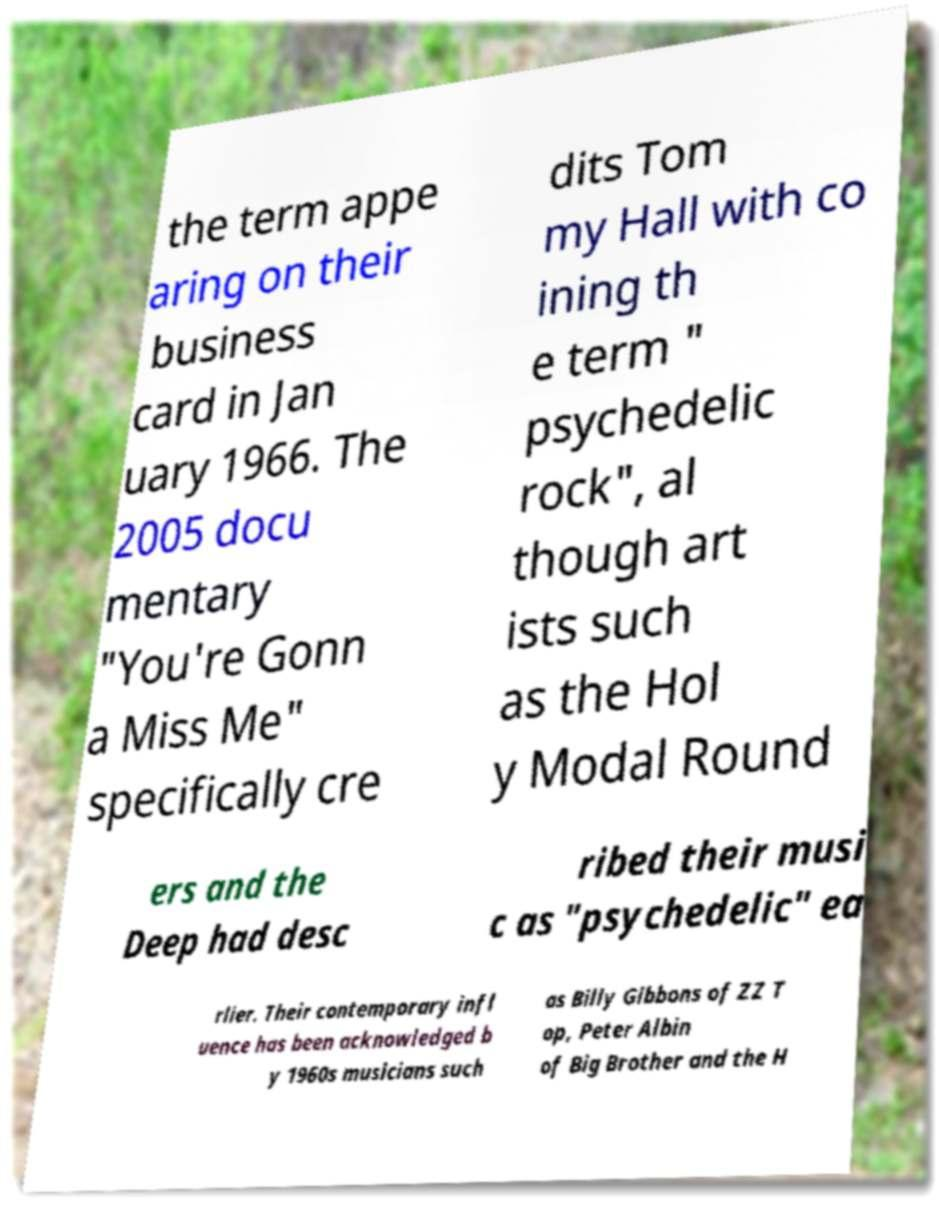There's text embedded in this image that I need extracted. Can you transcribe it verbatim? the term appe aring on their business card in Jan uary 1966. The 2005 docu mentary "You're Gonn a Miss Me" specifically cre dits Tom my Hall with co ining th e term " psychedelic rock", al though art ists such as the Hol y Modal Round ers and the Deep had desc ribed their musi c as "psychedelic" ea rlier. Their contemporary infl uence has been acknowledged b y 1960s musicians such as Billy Gibbons of ZZ T op, Peter Albin of Big Brother and the H 